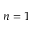<formula> <loc_0><loc_0><loc_500><loc_500>n = 1</formula> 